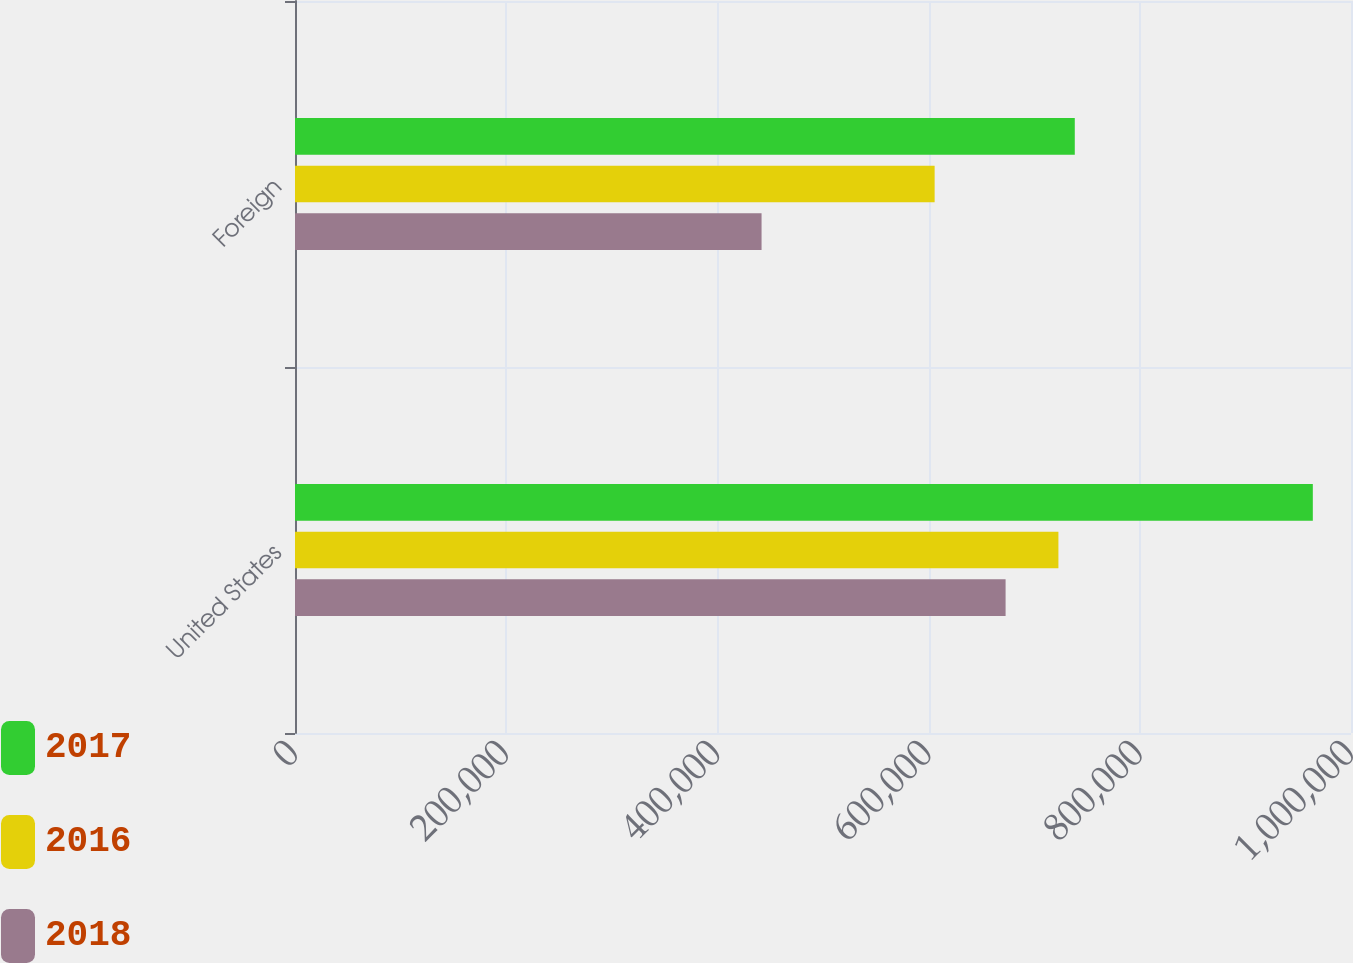Convert chart to OTSL. <chart><loc_0><loc_0><loc_500><loc_500><stacked_bar_chart><ecel><fcel>United States<fcel>Foreign<nl><fcel>2017<fcel>963843<fcel>738434<nl><fcel>2016<fcel>722925<fcel>605716<nl><fcel>2018<fcel>672907<fcel>441821<nl></chart> 